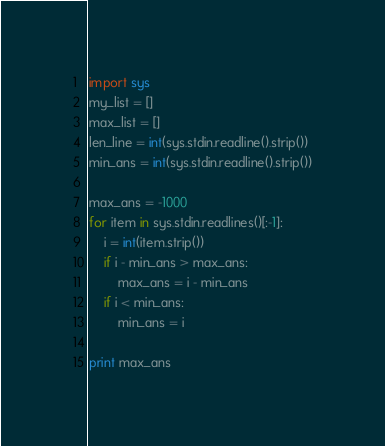<code> <loc_0><loc_0><loc_500><loc_500><_Python_>import sys
my_list = []
max_list = []
len_line = int(sys.stdin.readline().strip())
min_ans = int(sys.stdin.readline().strip())

max_ans = -1000
for item in sys.stdin.readlines()[:-1]:
    i = int(item.strip())
    if i - min_ans > max_ans:
        max_ans = i - min_ans
    if i < min_ans:
        min_ans = i

print max_ans</code> 